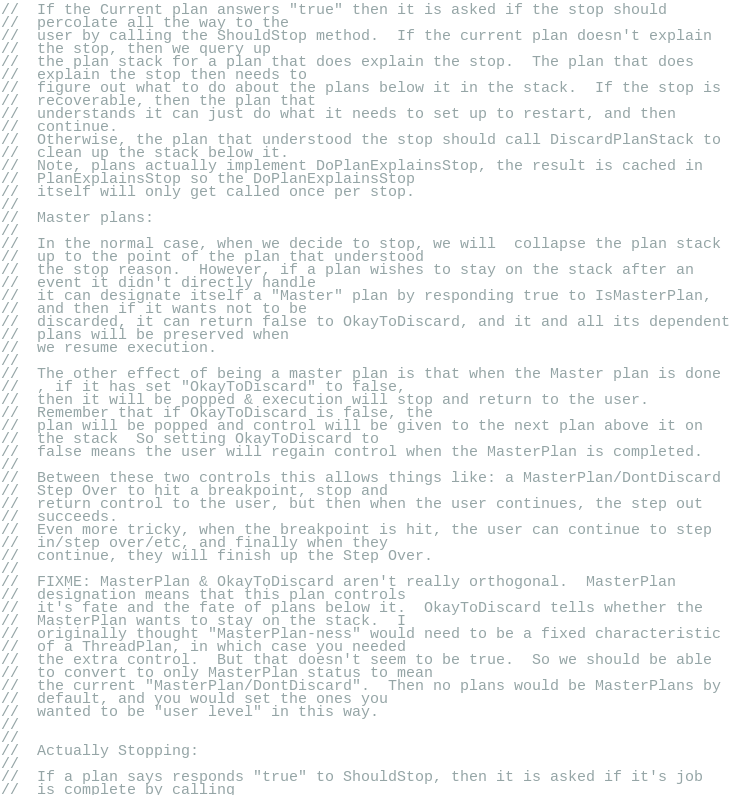Convert code to text. <code><loc_0><loc_0><loc_500><loc_500><_C_>//  If the Current plan answers "true" then it is asked if the stop should
//  percolate all the way to the
//  user by calling the ShouldStop method.  If the current plan doesn't explain
//  the stop, then we query up
//  the plan stack for a plan that does explain the stop.  The plan that does
//  explain the stop then needs to
//  figure out what to do about the plans below it in the stack.  If the stop is
//  recoverable, then the plan that
//  understands it can just do what it needs to set up to restart, and then
//  continue.
//  Otherwise, the plan that understood the stop should call DiscardPlanStack to
//  clean up the stack below it.
//  Note, plans actually implement DoPlanExplainsStop, the result is cached in
//  PlanExplainsStop so the DoPlanExplainsStop
//  itself will only get called once per stop.
//
//  Master plans:
//
//  In the normal case, when we decide to stop, we will  collapse the plan stack
//  up to the point of the plan that understood
//  the stop reason.  However, if a plan wishes to stay on the stack after an
//  event it didn't directly handle
//  it can designate itself a "Master" plan by responding true to IsMasterPlan,
//  and then if it wants not to be
//  discarded, it can return false to OkayToDiscard, and it and all its dependent
//  plans will be preserved when
//  we resume execution.
//
//  The other effect of being a master plan is that when the Master plan is done
//  , if it has set "OkayToDiscard" to false,
//  then it will be popped & execution will stop and return to the user.
//  Remember that if OkayToDiscard is false, the
//  plan will be popped and control will be given to the next plan above it on
//  the stack  So setting OkayToDiscard to
//  false means the user will regain control when the MasterPlan is completed.
//
//  Between these two controls this allows things like: a MasterPlan/DontDiscard
//  Step Over to hit a breakpoint, stop and
//  return control to the user, but then when the user continues, the step out
//  succeeds.
//  Even more tricky, when the breakpoint is hit, the user can continue to step
//  in/step over/etc, and finally when they
//  continue, they will finish up the Step Over.
//
//  FIXME: MasterPlan & OkayToDiscard aren't really orthogonal.  MasterPlan
//  designation means that this plan controls
//  it's fate and the fate of plans below it.  OkayToDiscard tells whether the
//  MasterPlan wants to stay on the stack.  I
//  originally thought "MasterPlan-ness" would need to be a fixed characteristic
//  of a ThreadPlan, in which case you needed
//  the extra control.  But that doesn't seem to be true.  So we should be able
//  to convert to only MasterPlan status to mean
//  the current "MasterPlan/DontDiscard".  Then no plans would be MasterPlans by
//  default, and you would set the ones you
//  wanted to be "user level" in this way.
//
//
//  Actually Stopping:
//
//  If a plan says responds "true" to ShouldStop, then it is asked if it's job
//  is complete by calling</code> 